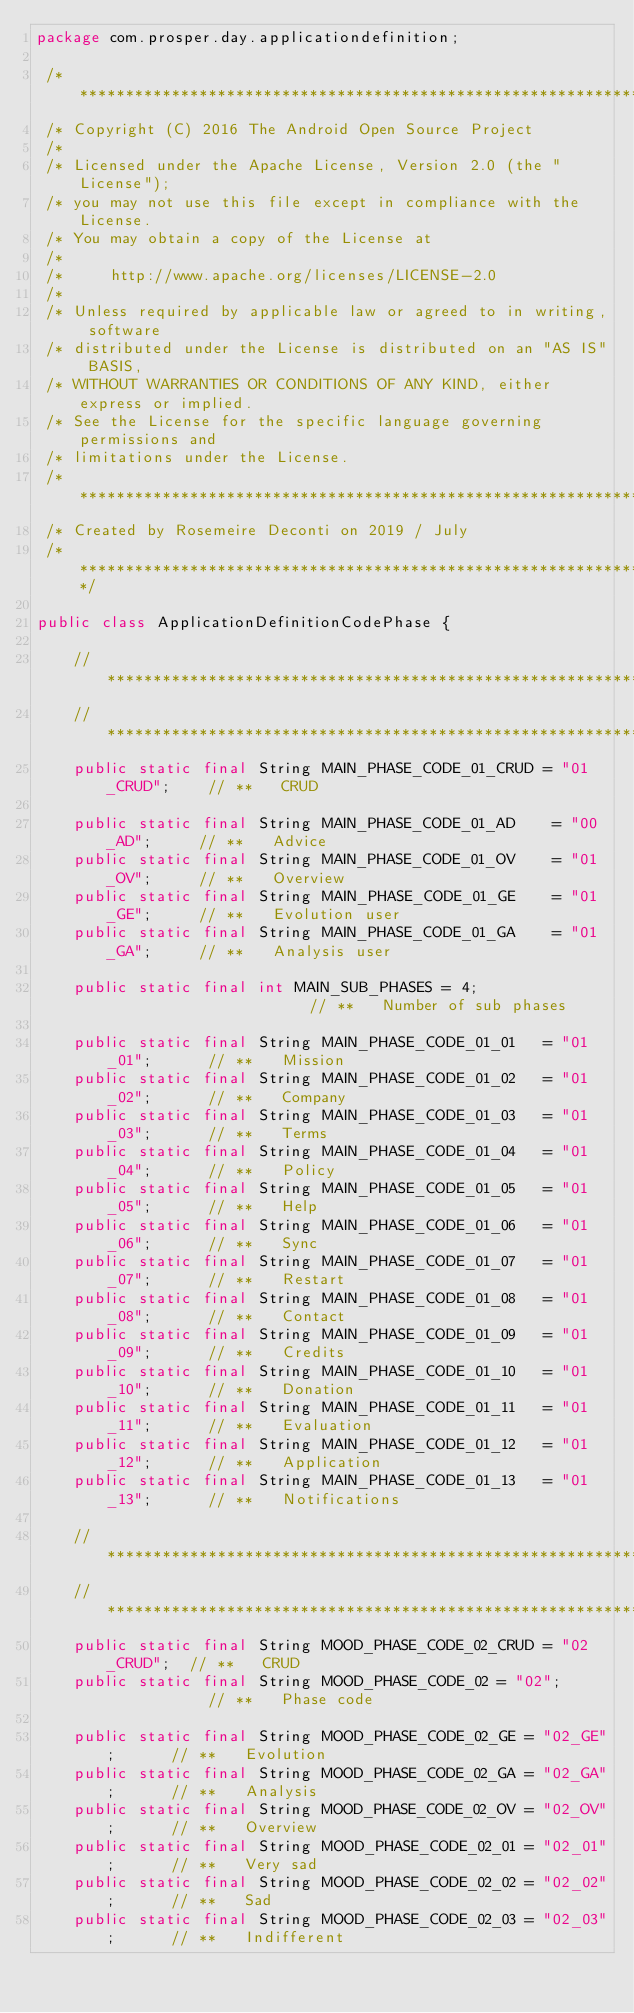Convert code to text. <code><loc_0><loc_0><loc_500><loc_500><_Java_>package com.prosper.day.applicationdefinition;

 /* ****************************************************************************
 /* Copyright (C) 2016 The Android Open Source Project
 /*
 /* Licensed under the Apache License, Version 2.0 (the "License");
 /* you may not use this file except in compliance with the License.
 /* You may obtain a copy of the License at
 /*
 /*     http://www.apache.org/licenses/LICENSE-2.0
 /*
 /* Unless required by applicable law or agreed to in writing, software
 /* distributed under the License is distributed on an "AS IS" BASIS,
 /* WITHOUT WARRANTIES OR CONDITIONS OF ANY KIND, either express or implied.
 /* See the License for the specific language governing permissions and
 /* limitations under the License.
 /* ****************************************************************************
 /* Created by Rosemeire Deconti on 2019 / July
 /* ****************************************************************************/

public class ApplicationDefinitionCodePhase {

    // *********************************************************************************************
    // *********************************************************************************************
    public static final String MAIN_PHASE_CODE_01_CRUD = "01_CRUD";    // **   CRUD

    public static final String MAIN_PHASE_CODE_01_AD    = "00_AD";     // **   Advice
    public static final String MAIN_PHASE_CODE_01_OV    = "01_OV";     // **   Overview
    public static final String MAIN_PHASE_CODE_01_GE    = "01_GE";     // **   Evolution user
    public static final String MAIN_PHASE_CODE_01_GA    = "01_GA";     // **   Analysis user

    public static final int MAIN_SUB_PHASES = 4;                       // **   Number of sub phases

    public static final String MAIN_PHASE_CODE_01_01   = "01_01";      // **   Mission
    public static final String MAIN_PHASE_CODE_01_02   = "01_02";      // **   Company
    public static final String MAIN_PHASE_CODE_01_03   = "01_03";      // **   Terms
    public static final String MAIN_PHASE_CODE_01_04   = "01_04";      // **   Policy
    public static final String MAIN_PHASE_CODE_01_05   = "01_05";      // **   Help
    public static final String MAIN_PHASE_CODE_01_06   = "01_06";      // **   Sync
    public static final String MAIN_PHASE_CODE_01_07   = "01_07";      // **   Restart
    public static final String MAIN_PHASE_CODE_01_08   = "01_08";      // **   Contact
    public static final String MAIN_PHASE_CODE_01_09   = "01_09";      // **   Credits
    public static final String MAIN_PHASE_CODE_01_10   = "01_10";      // **   Donation
    public static final String MAIN_PHASE_CODE_01_11   = "01_11";      // **   Evaluation
    public static final String MAIN_PHASE_CODE_01_12   = "01_12";      // **   Application
    public static final String MAIN_PHASE_CODE_01_13   = "01_13";      // **   Notifications

    // *********************************************************************************************
    // *********************************************************************************************
    public static final String MOOD_PHASE_CODE_02_CRUD = "02_CRUD";  // **   CRUD
    public static final String MOOD_PHASE_CODE_02 = "02";            // **   Phase code

    public static final String MOOD_PHASE_CODE_02_GE = "02_GE";      // **   Evolution
    public static final String MOOD_PHASE_CODE_02_GA = "02_GA";      // **   Analysis
    public static final String MOOD_PHASE_CODE_02_OV = "02_OV";      // **   Overview
    public static final String MOOD_PHASE_CODE_02_01 = "02_01";      // **   Very sad
    public static final String MOOD_PHASE_CODE_02_02 = "02_02";      // **   Sad
    public static final String MOOD_PHASE_CODE_02_03 = "02_03";      // **   Indifferent</code> 